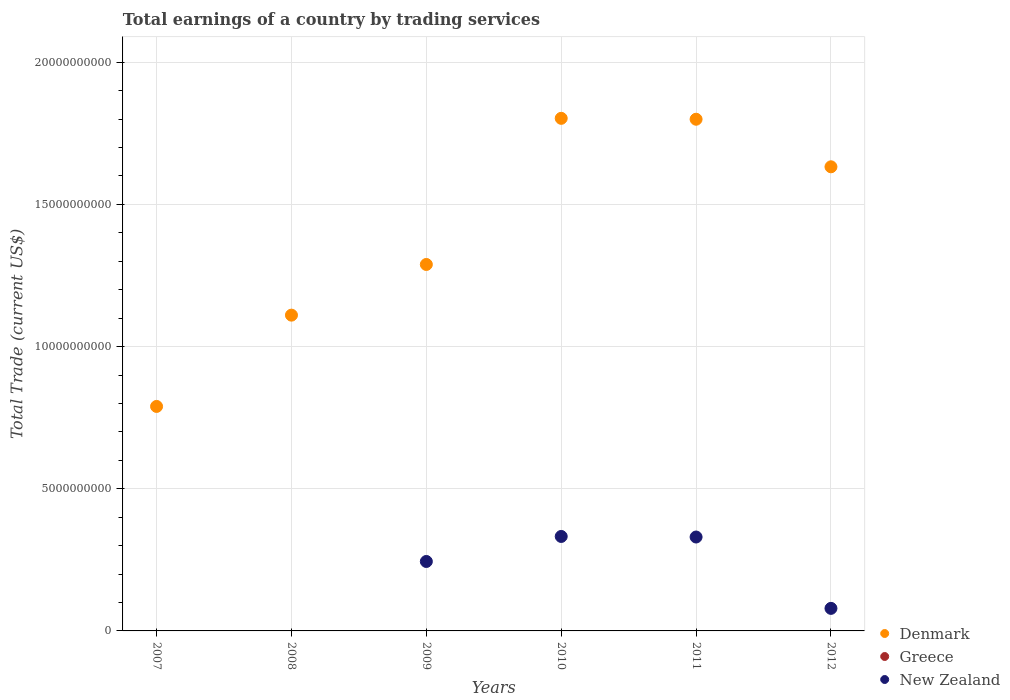Is the number of dotlines equal to the number of legend labels?
Keep it short and to the point. No. What is the total earnings in New Zealand in 2011?
Provide a succinct answer. 3.30e+09. Across all years, what is the maximum total earnings in New Zealand?
Offer a terse response. 3.32e+09. Across all years, what is the minimum total earnings in Greece?
Provide a short and direct response. 0. In which year was the total earnings in Denmark maximum?
Your response must be concise. 2010. What is the total total earnings in New Zealand in the graph?
Make the answer very short. 9.86e+09. What is the difference between the total earnings in New Zealand in 2009 and that in 2012?
Your answer should be compact. 1.65e+09. What is the difference between the total earnings in Greece in 2011 and the total earnings in Denmark in 2010?
Ensure brevity in your answer.  -1.80e+1. In the year 2009, what is the difference between the total earnings in New Zealand and total earnings in Denmark?
Give a very brief answer. -1.04e+1. What is the ratio of the total earnings in New Zealand in 2011 to that in 2012?
Provide a short and direct response. 4.16. Is the total earnings in Denmark in 2010 less than that in 2011?
Your response must be concise. No. What is the difference between the highest and the second highest total earnings in Denmark?
Make the answer very short. 3.18e+07. What is the difference between the highest and the lowest total earnings in New Zealand?
Your answer should be compact. 3.32e+09. In how many years, is the total earnings in Denmark greater than the average total earnings in Denmark taken over all years?
Your response must be concise. 3. Is the sum of the total earnings in Denmark in 2008 and 2010 greater than the maximum total earnings in New Zealand across all years?
Keep it short and to the point. Yes. Is it the case that in every year, the sum of the total earnings in Greece and total earnings in New Zealand  is greater than the total earnings in Denmark?
Keep it short and to the point. No. Does the total earnings in Denmark monotonically increase over the years?
Ensure brevity in your answer.  No. Is the total earnings in Greece strictly greater than the total earnings in New Zealand over the years?
Give a very brief answer. No. How many years are there in the graph?
Your answer should be very brief. 6. Where does the legend appear in the graph?
Offer a terse response. Bottom right. How are the legend labels stacked?
Your response must be concise. Vertical. What is the title of the graph?
Ensure brevity in your answer.  Total earnings of a country by trading services. Does "East Asia (developing only)" appear as one of the legend labels in the graph?
Your answer should be very brief. No. What is the label or title of the Y-axis?
Your answer should be very brief. Total Trade (current US$). What is the Total Trade (current US$) in Denmark in 2007?
Make the answer very short. 7.89e+09. What is the Total Trade (current US$) in Denmark in 2008?
Your answer should be very brief. 1.11e+1. What is the Total Trade (current US$) in New Zealand in 2008?
Your answer should be compact. 0. What is the Total Trade (current US$) of Denmark in 2009?
Provide a short and direct response. 1.29e+1. What is the Total Trade (current US$) of New Zealand in 2009?
Provide a succinct answer. 2.44e+09. What is the Total Trade (current US$) of Denmark in 2010?
Ensure brevity in your answer.  1.80e+1. What is the Total Trade (current US$) of New Zealand in 2010?
Your answer should be compact. 3.32e+09. What is the Total Trade (current US$) in Denmark in 2011?
Offer a very short reply. 1.80e+1. What is the Total Trade (current US$) of New Zealand in 2011?
Make the answer very short. 3.30e+09. What is the Total Trade (current US$) in Denmark in 2012?
Offer a very short reply. 1.63e+1. What is the Total Trade (current US$) in Greece in 2012?
Give a very brief answer. 0. What is the Total Trade (current US$) of New Zealand in 2012?
Provide a short and direct response. 7.93e+08. Across all years, what is the maximum Total Trade (current US$) in Denmark?
Your answer should be very brief. 1.80e+1. Across all years, what is the maximum Total Trade (current US$) of New Zealand?
Provide a short and direct response. 3.32e+09. Across all years, what is the minimum Total Trade (current US$) of Denmark?
Make the answer very short. 7.89e+09. Across all years, what is the minimum Total Trade (current US$) of New Zealand?
Make the answer very short. 0. What is the total Total Trade (current US$) in Denmark in the graph?
Offer a terse response. 8.42e+1. What is the total Total Trade (current US$) of New Zealand in the graph?
Offer a very short reply. 9.86e+09. What is the difference between the Total Trade (current US$) in Denmark in 2007 and that in 2008?
Provide a succinct answer. -3.21e+09. What is the difference between the Total Trade (current US$) of Denmark in 2007 and that in 2009?
Your response must be concise. -4.99e+09. What is the difference between the Total Trade (current US$) in Denmark in 2007 and that in 2010?
Keep it short and to the point. -1.01e+1. What is the difference between the Total Trade (current US$) of Denmark in 2007 and that in 2011?
Keep it short and to the point. -1.01e+1. What is the difference between the Total Trade (current US$) of Denmark in 2007 and that in 2012?
Offer a very short reply. -8.43e+09. What is the difference between the Total Trade (current US$) of Denmark in 2008 and that in 2009?
Offer a very short reply. -1.78e+09. What is the difference between the Total Trade (current US$) in Denmark in 2008 and that in 2010?
Give a very brief answer. -6.92e+09. What is the difference between the Total Trade (current US$) of Denmark in 2008 and that in 2011?
Your response must be concise. -6.89e+09. What is the difference between the Total Trade (current US$) in Denmark in 2008 and that in 2012?
Provide a short and direct response. -5.22e+09. What is the difference between the Total Trade (current US$) in Denmark in 2009 and that in 2010?
Provide a short and direct response. -5.14e+09. What is the difference between the Total Trade (current US$) of New Zealand in 2009 and that in 2010?
Provide a short and direct response. -8.80e+08. What is the difference between the Total Trade (current US$) in Denmark in 2009 and that in 2011?
Make the answer very short. -5.11e+09. What is the difference between the Total Trade (current US$) of New Zealand in 2009 and that in 2011?
Provide a succinct answer. -8.60e+08. What is the difference between the Total Trade (current US$) in Denmark in 2009 and that in 2012?
Give a very brief answer. -3.43e+09. What is the difference between the Total Trade (current US$) in New Zealand in 2009 and that in 2012?
Provide a short and direct response. 1.65e+09. What is the difference between the Total Trade (current US$) of Denmark in 2010 and that in 2011?
Offer a very short reply. 3.18e+07. What is the difference between the Total Trade (current US$) of New Zealand in 2010 and that in 2011?
Provide a succinct answer. 1.99e+07. What is the difference between the Total Trade (current US$) in Denmark in 2010 and that in 2012?
Keep it short and to the point. 1.70e+09. What is the difference between the Total Trade (current US$) in New Zealand in 2010 and that in 2012?
Provide a short and direct response. 2.53e+09. What is the difference between the Total Trade (current US$) of Denmark in 2011 and that in 2012?
Keep it short and to the point. 1.67e+09. What is the difference between the Total Trade (current US$) in New Zealand in 2011 and that in 2012?
Your answer should be compact. 2.51e+09. What is the difference between the Total Trade (current US$) in Denmark in 2007 and the Total Trade (current US$) in New Zealand in 2009?
Provide a succinct answer. 5.45e+09. What is the difference between the Total Trade (current US$) of Denmark in 2007 and the Total Trade (current US$) of New Zealand in 2010?
Provide a short and direct response. 4.57e+09. What is the difference between the Total Trade (current US$) of Denmark in 2007 and the Total Trade (current US$) of New Zealand in 2011?
Make the answer very short. 4.59e+09. What is the difference between the Total Trade (current US$) of Denmark in 2007 and the Total Trade (current US$) of New Zealand in 2012?
Keep it short and to the point. 7.10e+09. What is the difference between the Total Trade (current US$) in Denmark in 2008 and the Total Trade (current US$) in New Zealand in 2009?
Your answer should be compact. 8.66e+09. What is the difference between the Total Trade (current US$) in Denmark in 2008 and the Total Trade (current US$) in New Zealand in 2010?
Your answer should be compact. 7.78e+09. What is the difference between the Total Trade (current US$) of Denmark in 2008 and the Total Trade (current US$) of New Zealand in 2011?
Provide a succinct answer. 7.80e+09. What is the difference between the Total Trade (current US$) in Denmark in 2008 and the Total Trade (current US$) in New Zealand in 2012?
Ensure brevity in your answer.  1.03e+1. What is the difference between the Total Trade (current US$) in Denmark in 2009 and the Total Trade (current US$) in New Zealand in 2010?
Make the answer very short. 9.56e+09. What is the difference between the Total Trade (current US$) in Denmark in 2009 and the Total Trade (current US$) in New Zealand in 2011?
Provide a short and direct response. 9.58e+09. What is the difference between the Total Trade (current US$) in Denmark in 2009 and the Total Trade (current US$) in New Zealand in 2012?
Give a very brief answer. 1.21e+1. What is the difference between the Total Trade (current US$) in Denmark in 2010 and the Total Trade (current US$) in New Zealand in 2011?
Make the answer very short. 1.47e+1. What is the difference between the Total Trade (current US$) of Denmark in 2010 and the Total Trade (current US$) of New Zealand in 2012?
Your answer should be very brief. 1.72e+1. What is the difference between the Total Trade (current US$) in Denmark in 2011 and the Total Trade (current US$) in New Zealand in 2012?
Provide a short and direct response. 1.72e+1. What is the average Total Trade (current US$) in Denmark per year?
Your answer should be compact. 1.40e+1. What is the average Total Trade (current US$) in New Zealand per year?
Your answer should be very brief. 1.64e+09. In the year 2009, what is the difference between the Total Trade (current US$) in Denmark and Total Trade (current US$) in New Zealand?
Give a very brief answer. 1.04e+1. In the year 2010, what is the difference between the Total Trade (current US$) of Denmark and Total Trade (current US$) of New Zealand?
Offer a terse response. 1.47e+1. In the year 2011, what is the difference between the Total Trade (current US$) in Denmark and Total Trade (current US$) in New Zealand?
Keep it short and to the point. 1.47e+1. In the year 2012, what is the difference between the Total Trade (current US$) in Denmark and Total Trade (current US$) in New Zealand?
Make the answer very short. 1.55e+1. What is the ratio of the Total Trade (current US$) of Denmark in 2007 to that in 2008?
Provide a succinct answer. 0.71. What is the ratio of the Total Trade (current US$) in Denmark in 2007 to that in 2009?
Give a very brief answer. 0.61. What is the ratio of the Total Trade (current US$) in Denmark in 2007 to that in 2010?
Your response must be concise. 0.44. What is the ratio of the Total Trade (current US$) of Denmark in 2007 to that in 2011?
Offer a terse response. 0.44. What is the ratio of the Total Trade (current US$) in Denmark in 2007 to that in 2012?
Your answer should be compact. 0.48. What is the ratio of the Total Trade (current US$) of Denmark in 2008 to that in 2009?
Your response must be concise. 0.86. What is the ratio of the Total Trade (current US$) in Denmark in 2008 to that in 2010?
Your answer should be compact. 0.62. What is the ratio of the Total Trade (current US$) of Denmark in 2008 to that in 2011?
Offer a terse response. 0.62. What is the ratio of the Total Trade (current US$) of Denmark in 2008 to that in 2012?
Ensure brevity in your answer.  0.68. What is the ratio of the Total Trade (current US$) of Denmark in 2009 to that in 2010?
Your answer should be very brief. 0.71. What is the ratio of the Total Trade (current US$) in New Zealand in 2009 to that in 2010?
Ensure brevity in your answer.  0.74. What is the ratio of the Total Trade (current US$) in Denmark in 2009 to that in 2011?
Your answer should be very brief. 0.72. What is the ratio of the Total Trade (current US$) of New Zealand in 2009 to that in 2011?
Offer a terse response. 0.74. What is the ratio of the Total Trade (current US$) in Denmark in 2009 to that in 2012?
Provide a short and direct response. 0.79. What is the ratio of the Total Trade (current US$) of New Zealand in 2009 to that in 2012?
Give a very brief answer. 3.08. What is the ratio of the Total Trade (current US$) of Denmark in 2010 to that in 2011?
Ensure brevity in your answer.  1. What is the ratio of the Total Trade (current US$) in New Zealand in 2010 to that in 2011?
Offer a very short reply. 1.01. What is the ratio of the Total Trade (current US$) in Denmark in 2010 to that in 2012?
Your response must be concise. 1.1. What is the ratio of the Total Trade (current US$) in New Zealand in 2010 to that in 2012?
Offer a terse response. 4.19. What is the ratio of the Total Trade (current US$) of Denmark in 2011 to that in 2012?
Your answer should be compact. 1.1. What is the ratio of the Total Trade (current US$) of New Zealand in 2011 to that in 2012?
Your response must be concise. 4.16. What is the difference between the highest and the second highest Total Trade (current US$) of Denmark?
Ensure brevity in your answer.  3.18e+07. What is the difference between the highest and the second highest Total Trade (current US$) of New Zealand?
Ensure brevity in your answer.  1.99e+07. What is the difference between the highest and the lowest Total Trade (current US$) in Denmark?
Offer a terse response. 1.01e+1. What is the difference between the highest and the lowest Total Trade (current US$) in New Zealand?
Your response must be concise. 3.32e+09. 